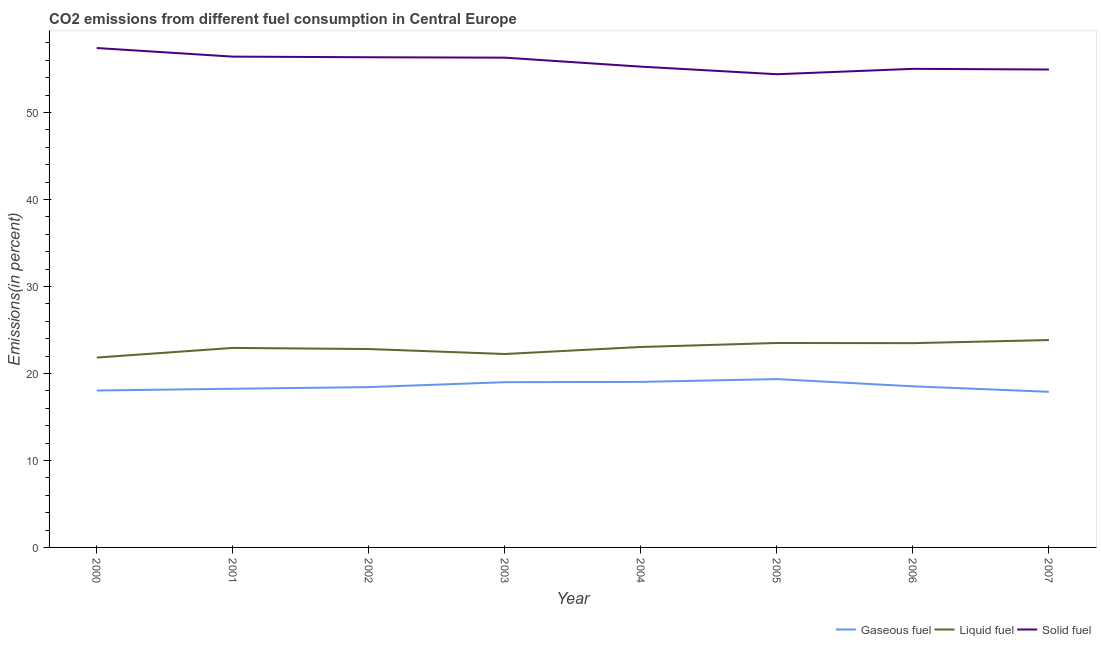Is the number of lines equal to the number of legend labels?
Your answer should be compact. Yes. What is the percentage of gaseous fuel emission in 2001?
Your answer should be very brief. 18.24. Across all years, what is the maximum percentage of liquid fuel emission?
Provide a short and direct response. 23.84. Across all years, what is the minimum percentage of gaseous fuel emission?
Your answer should be compact. 17.89. In which year was the percentage of solid fuel emission maximum?
Your response must be concise. 2000. In which year was the percentage of gaseous fuel emission minimum?
Your response must be concise. 2007. What is the total percentage of solid fuel emission in the graph?
Your response must be concise. 446.14. What is the difference between the percentage of solid fuel emission in 2001 and that in 2005?
Your response must be concise. 2.02. What is the difference between the percentage of liquid fuel emission in 2007 and the percentage of gaseous fuel emission in 2004?
Offer a very short reply. 4.81. What is the average percentage of liquid fuel emission per year?
Your answer should be very brief. 22.96. In the year 2002, what is the difference between the percentage of liquid fuel emission and percentage of gaseous fuel emission?
Give a very brief answer. 4.38. In how many years, is the percentage of gaseous fuel emission greater than 4 %?
Offer a terse response. 8. What is the ratio of the percentage of gaseous fuel emission in 2004 to that in 2007?
Offer a very short reply. 1.06. Is the percentage of solid fuel emission in 2001 less than that in 2004?
Provide a short and direct response. No. What is the difference between the highest and the second highest percentage of liquid fuel emission?
Ensure brevity in your answer.  0.34. What is the difference between the highest and the lowest percentage of gaseous fuel emission?
Ensure brevity in your answer.  1.46. Is the sum of the percentage of liquid fuel emission in 2006 and 2007 greater than the maximum percentage of gaseous fuel emission across all years?
Your response must be concise. Yes. Is it the case that in every year, the sum of the percentage of gaseous fuel emission and percentage of liquid fuel emission is greater than the percentage of solid fuel emission?
Your answer should be very brief. No. Does the percentage of gaseous fuel emission monotonically increase over the years?
Provide a succinct answer. No. Is the percentage of gaseous fuel emission strictly less than the percentage of liquid fuel emission over the years?
Keep it short and to the point. Yes. How many lines are there?
Provide a short and direct response. 3. How many years are there in the graph?
Make the answer very short. 8. Are the values on the major ticks of Y-axis written in scientific E-notation?
Provide a short and direct response. No. Does the graph contain grids?
Offer a terse response. No. What is the title of the graph?
Your answer should be compact. CO2 emissions from different fuel consumption in Central Europe. What is the label or title of the X-axis?
Your answer should be compact. Year. What is the label or title of the Y-axis?
Offer a terse response. Emissions(in percent). What is the Emissions(in percent) of Gaseous fuel in 2000?
Offer a terse response. 18.04. What is the Emissions(in percent) in Liquid fuel in 2000?
Make the answer very short. 21.83. What is the Emissions(in percent) in Solid fuel in 2000?
Offer a terse response. 57.42. What is the Emissions(in percent) in Gaseous fuel in 2001?
Provide a short and direct response. 18.24. What is the Emissions(in percent) in Liquid fuel in 2001?
Give a very brief answer. 22.94. What is the Emissions(in percent) in Solid fuel in 2001?
Your response must be concise. 56.43. What is the Emissions(in percent) in Gaseous fuel in 2002?
Offer a very short reply. 18.43. What is the Emissions(in percent) in Liquid fuel in 2002?
Make the answer very short. 22.81. What is the Emissions(in percent) of Solid fuel in 2002?
Your answer should be very brief. 56.35. What is the Emissions(in percent) of Gaseous fuel in 2003?
Make the answer very short. 19. What is the Emissions(in percent) in Liquid fuel in 2003?
Offer a terse response. 22.24. What is the Emissions(in percent) in Solid fuel in 2003?
Make the answer very short. 56.31. What is the Emissions(in percent) in Gaseous fuel in 2004?
Offer a very short reply. 19.03. What is the Emissions(in percent) in Liquid fuel in 2004?
Offer a terse response. 23.04. What is the Emissions(in percent) of Solid fuel in 2004?
Your answer should be very brief. 55.27. What is the Emissions(in percent) of Gaseous fuel in 2005?
Offer a terse response. 19.35. What is the Emissions(in percent) of Liquid fuel in 2005?
Provide a short and direct response. 23.5. What is the Emissions(in percent) in Solid fuel in 2005?
Provide a short and direct response. 54.4. What is the Emissions(in percent) of Gaseous fuel in 2006?
Keep it short and to the point. 18.52. What is the Emissions(in percent) in Liquid fuel in 2006?
Your answer should be very brief. 23.48. What is the Emissions(in percent) in Solid fuel in 2006?
Make the answer very short. 55.02. What is the Emissions(in percent) in Gaseous fuel in 2007?
Offer a terse response. 17.89. What is the Emissions(in percent) of Liquid fuel in 2007?
Provide a short and direct response. 23.84. What is the Emissions(in percent) of Solid fuel in 2007?
Ensure brevity in your answer.  54.94. Across all years, what is the maximum Emissions(in percent) in Gaseous fuel?
Keep it short and to the point. 19.35. Across all years, what is the maximum Emissions(in percent) in Liquid fuel?
Offer a terse response. 23.84. Across all years, what is the maximum Emissions(in percent) of Solid fuel?
Make the answer very short. 57.42. Across all years, what is the minimum Emissions(in percent) of Gaseous fuel?
Offer a very short reply. 17.89. Across all years, what is the minimum Emissions(in percent) of Liquid fuel?
Your answer should be very brief. 21.83. Across all years, what is the minimum Emissions(in percent) of Solid fuel?
Your answer should be compact. 54.4. What is the total Emissions(in percent) in Gaseous fuel in the graph?
Give a very brief answer. 148.51. What is the total Emissions(in percent) in Liquid fuel in the graph?
Provide a short and direct response. 183.69. What is the total Emissions(in percent) of Solid fuel in the graph?
Offer a terse response. 446.14. What is the difference between the Emissions(in percent) of Gaseous fuel in 2000 and that in 2001?
Your answer should be very brief. -0.2. What is the difference between the Emissions(in percent) in Liquid fuel in 2000 and that in 2001?
Offer a terse response. -1.11. What is the difference between the Emissions(in percent) in Gaseous fuel in 2000 and that in 2002?
Provide a short and direct response. -0.39. What is the difference between the Emissions(in percent) of Liquid fuel in 2000 and that in 2002?
Keep it short and to the point. -0.98. What is the difference between the Emissions(in percent) of Solid fuel in 2000 and that in 2002?
Offer a terse response. 1.06. What is the difference between the Emissions(in percent) in Gaseous fuel in 2000 and that in 2003?
Make the answer very short. -0.96. What is the difference between the Emissions(in percent) in Liquid fuel in 2000 and that in 2003?
Give a very brief answer. -0.41. What is the difference between the Emissions(in percent) of Solid fuel in 2000 and that in 2003?
Your answer should be compact. 1.11. What is the difference between the Emissions(in percent) in Gaseous fuel in 2000 and that in 2004?
Your answer should be very brief. -0.99. What is the difference between the Emissions(in percent) in Liquid fuel in 2000 and that in 2004?
Provide a short and direct response. -1.21. What is the difference between the Emissions(in percent) of Solid fuel in 2000 and that in 2004?
Your answer should be compact. 2.14. What is the difference between the Emissions(in percent) of Gaseous fuel in 2000 and that in 2005?
Your response must be concise. -1.31. What is the difference between the Emissions(in percent) of Liquid fuel in 2000 and that in 2005?
Keep it short and to the point. -1.67. What is the difference between the Emissions(in percent) of Solid fuel in 2000 and that in 2005?
Your answer should be very brief. 3.01. What is the difference between the Emissions(in percent) in Gaseous fuel in 2000 and that in 2006?
Offer a very short reply. -0.48. What is the difference between the Emissions(in percent) in Liquid fuel in 2000 and that in 2006?
Keep it short and to the point. -1.65. What is the difference between the Emissions(in percent) in Solid fuel in 2000 and that in 2006?
Give a very brief answer. 2.39. What is the difference between the Emissions(in percent) of Gaseous fuel in 2000 and that in 2007?
Offer a very short reply. 0.15. What is the difference between the Emissions(in percent) of Liquid fuel in 2000 and that in 2007?
Offer a terse response. -2.01. What is the difference between the Emissions(in percent) of Solid fuel in 2000 and that in 2007?
Your answer should be very brief. 2.47. What is the difference between the Emissions(in percent) of Gaseous fuel in 2001 and that in 2002?
Offer a terse response. -0.19. What is the difference between the Emissions(in percent) in Liquid fuel in 2001 and that in 2002?
Offer a terse response. 0.13. What is the difference between the Emissions(in percent) in Solid fuel in 2001 and that in 2002?
Keep it short and to the point. 0.07. What is the difference between the Emissions(in percent) in Gaseous fuel in 2001 and that in 2003?
Offer a terse response. -0.76. What is the difference between the Emissions(in percent) in Liquid fuel in 2001 and that in 2003?
Provide a short and direct response. 0.7. What is the difference between the Emissions(in percent) in Solid fuel in 2001 and that in 2003?
Give a very brief answer. 0.12. What is the difference between the Emissions(in percent) of Gaseous fuel in 2001 and that in 2004?
Keep it short and to the point. -0.79. What is the difference between the Emissions(in percent) of Liquid fuel in 2001 and that in 2004?
Provide a succinct answer. -0.11. What is the difference between the Emissions(in percent) in Solid fuel in 2001 and that in 2004?
Give a very brief answer. 1.15. What is the difference between the Emissions(in percent) in Gaseous fuel in 2001 and that in 2005?
Your response must be concise. -1.11. What is the difference between the Emissions(in percent) of Liquid fuel in 2001 and that in 2005?
Make the answer very short. -0.57. What is the difference between the Emissions(in percent) of Solid fuel in 2001 and that in 2005?
Give a very brief answer. 2.02. What is the difference between the Emissions(in percent) in Gaseous fuel in 2001 and that in 2006?
Your response must be concise. -0.28. What is the difference between the Emissions(in percent) of Liquid fuel in 2001 and that in 2006?
Your answer should be compact. -0.55. What is the difference between the Emissions(in percent) of Solid fuel in 2001 and that in 2006?
Ensure brevity in your answer.  1.4. What is the difference between the Emissions(in percent) of Gaseous fuel in 2001 and that in 2007?
Make the answer very short. 0.35. What is the difference between the Emissions(in percent) in Liquid fuel in 2001 and that in 2007?
Your answer should be compact. -0.91. What is the difference between the Emissions(in percent) of Solid fuel in 2001 and that in 2007?
Provide a short and direct response. 1.48. What is the difference between the Emissions(in percent) in Gaseous fuel in 2002 and that in 2003?
Your answer should be very brief. -0.57. What is the difference between the Emissions(in percent) in Liquid fuel in 2002 and that in 2003?
Your answer should be compact. 0.57. What is the difference between the Emissions(in percent) in Solid fuel in 2002 and that in 2003?
Your answer should be very brief. 0.05. What is the difference between the Emissions(in percent) of Gaseous fuel in 2002 and that in 2004?
Give a very brief answer. -0.6. What is the difference between the Emissions(in percent) in Liquid fuel in 2002 and that in 2004?
Your answer should be very brief. -0.24. What is the difference between the Emissions(in percent) in Solid fuel in 2002 and that in 2004?
Your response must be concise. 1.08. What is the difference between the Emissions(in percent) of Gaseous fuel in 2002 and that in 2005?
Your response must be concise. -0.92. What is the difference between the Emissions(in percent) of Liquid fuel in 2002 and that in 2005?
Your answer should be compact. -0.7. What is the difference between the Emissions(in percent) of Solid fuel in 2002 and that in 2005?
Your answer should be compact. 1.95. What is the difference between the Emissions(in percent) of Gaseous fuel in 2002 and that in 2006?
Ensure brevity in your answer.  -0.09. What is the difference between the Emissions(in percent) in Liquid fuel in 2002 and that in 2006?
Offer a terse response. -0.68. What is the difference between the Emissions(in percent) in Solid fuel in 2002 and that in 2006?
Keep it short and to the point. 1.33. What is the difference between the Emissions(in percent) of Gaseous fuel in 2002 and that in 2007?
Offer a terse response. 0.54. What is the difference between the Emissions(in percent) in Liquid fuel in 2002 and that in 2007?
Keep it short and to the point. -1.03. What is the difference between the Emissions(in percent) of Solid fuel in 2002 and that in 2007?
Your answer should be very brief. 1.41. What is the difference between the Emissions(in percent) of Gaseous fuel in 2003 and that in 2004?
Ensure brevity in your answer.  -0.03. What is the difference between the Emissions(in percent) of Liquid fuel in 2003 and that in 2004?
Provide a succinct answer. -0.81. What is the difference between the Emissions(in percent) in Solid fuel in 2003 and that in 2004?
Offer a terse response. 1.03. What is the difference between the Emissions(in percent) of Gaseous fuel in 2003 and that in 2005?
Offer a very short reply. -0.36. What is the difference between the Emissions(in percent) of Liquid fuel in 2003 and that in 2005?
Your answer should be compact. -1.27. What is the difference between the Emissions(in percent) of Solid fuel in 2003 and that in 2005?
Make the answer very short. 1.91. What is the difference between the Emissions(in percent) of Gaseous fuel in 2003 and that in 2006?
Give a very brief answer. 0.47. What is the difference between the Emissions(in percent) in Liquid fuel in 2003 and that in 2006?
Your answer should be compact. -1.25. What is the difference between the Emissions(in percent) in Solid fuel in 2003 and that in 2006?
Your answer should be compact. 1.29. What is the difference between the Emissions(in percent) in Gaseous fuel in 2003 and that in 2007?
Give a very brief answer. 1.11. What is the difference between the Emissions(in percent) in Liquid fuel in 2003 and that in 2007?
Provide a short and direct response. -1.6. What is the difference between the Emissions(in percent) of Solid fuel in 2003 and that in 2007?
Make the answer very short. 1.36. What is the difference between the Emissions(in percent) of Gaseous fuel in 2004 and that in 2005?
Give a very brief answer. -0.32. What is the difference between the Emissions(in percent) in Liquid fuel in 2004 and that in 2005?
Offer a terse response. -0.46. What is the difference between the Emissions(in percent) in Solid fuel in 2004 and that in 2005?
Your response must be concise. 0.87. What is the difference between the Emissions(in percent) in Gaseous fuel in 2004 and that in 2006?
Ensure brevity in your answer.  0.51. What is the difference between the Emissions(in percent) in Liquid fuel in 2004 and that in 2006?
Provide a succinct answer. -0.44. What is the difference between the Emissions(in percent) of Solid fuel in 2004 and that in 2006?
Provide a short and direct response. 0.25. What is the difference between the Emissions(in percent) of Gaseous fuel in 2004 and that in 2007?
Offer a terse response. 1.14. What is the difference between the Emissions(in percent) in Liquid fuel in 2004 and that in 2007?
Ensure brevity in your answer.  -0.8. What is the difference between the Emissions(in percent) of Solid fuel in 2004 and that in 2007?
Provide a short and direct response. 0.33. What is the difference between the Emissions(in percent) in Gaseous fuel in 2005 and that in 2006?
Ensure brevity in your answer.  0.83. What is the difference between the Emissions(in percent) in Liquid fuel in 2005 and that in 2006?
Provide a succinct answer. 0.02. What is the difference between the Emissions(in percent) in Solid fuel in 2005 and that in 2006?
Offer a very short reply. -0.62. What is the difference between the Emissions(in percent) in Gaseous fuel in 2005 and that in 2007?
Offer a very short reply. 1.46. What is the difference between the Emissions(in percent) of Liquid fuel in 2005 and that in 2007?
Ensure brevity in your answer.  -0.34. What is the difference between the Emissions(in percent) of Solid fuel in 2005 and that in 2007?
Make the answer very short. -0.54. What is the difference between the Emissions(in percent) of Gaseous fuel in 2006 and that in 2007?
Your answer should be very brief. 0.63. What is the difference between the Emissions(in percent) in Liquid fuel in 2006 and that in 2007?
Your answer should be compact. -0.36. What is the difference between the Emissions(in percent) of Solid fuel in 2006 and that in 2007?
Keep it short and to the point. 0.08. What is the difference between the Emissions(in percent) of Gaseous fuel in 2000 and the Emissions(in percent) of Liquid fuel in 2001?
Offer a terse response. -4.9. What is the difference between the Emissions(in percent) in Gaseous fuel in 2000 and the Emissions(in percent) in Solid fuel in 2001?
Provide a succinct answer. -38.39. What is the difference between the Emissions(in percent) in Liquid fuel in 2000 and the Emissions(in percent) in Solid fuel in 2001?
Your answer should be very brief. -34.6. What is the difference between the Emissions(in percent) in Gaseous fuel in 2000 and the Emissions(in percent) in Liquid fuel in 2002?
Ensure brevity in your answer.  -4.77. What is the difference between the Emissions(in percent) of Gaseous fuel in 2000 and the Emissions(in percent) of Solid fuel in 2002?
Offer a very short reply. -38.31. What is the difference between the Emissions(in percent) in Liquid fuel in 2000 and the Emissions(in percent) in Solid fuel in 2002?
Your answer should be very brief. -34.52. What is the difference between the Emissions(in percent) of Gaseous fuel in 2000 and the Emissions(in percent) of Liquid fuel in 2003?
Your response must be concise. -4.2. What is the difference between the Emissions(in percent) of Gaseous fuel in 2000 and the Emissions(in percent) of Solid fuel in 2003?
Provide a short and direct response. -38.27. What is the difference between the Emissions(in percent) of Liquid fuel in 2000 and the Emissions(in percent) of Solid fuel in 2003?
Your answer should be compact. -34.48. What is the difference between the Emissions(in percent) of Gaseous fuel in 2000 and the Emissions(in percent) of Liquid fuel in 2004?
Your response must be concise. -5. What is the difference between the Emissions(in percent) in Gaseous fuel in 2000 and the Emissions(in percent) in Solid fuel in 2004?
Offer a very short reply. -37.23. What is the difference between the Emissions(in percent) of Liquid fuel in 2000 and the Emissions(in percent) of Solid fuel in 2004?
Your answer should be very brief. -33.44. What is the difference between the Emissions(in percent) of Gaseous fuel in 2000 and the Emissions(in percent) of Liquid fuel in 2005?
Offer a very short reply. -5.46. What is the difference between the Emissions(in percent) in Gaseous fuel in 2000 and the Emissions(in percent) in Solid fuel in 2005?
Offer a very short reply. -36.36. What is the difference between the Emissions(in percent) of Liquid fuel in 2000 and the Emissions(in percent) of Solid fuel in 2005?
Your response must be concise. -32.57. What is the difference between the Emissions(in percent) in Gaseous fuel in 2000 and the Emissions(in percent) in Liquid fuel in 2006?
Your answer should be very brief. -5.44. What is the difference between the Emissions(in percent) in Gaseous fuel in 2000 and the Emissions(in percent) in Solid fuel in 2006?
Your answer should be compact. -36.98. What is the difference between the Emissions(in percent) of Liquid fuel in 2000 and the Emissions(in percent) of Solid fuel in 2006?
Keep it short and to the point. -33.19. What is the difference between the Emissions(in percent) in Gaseous fuel in 2000 and the Emissions(in percent) in Liquid fuel in 2007?
Offer a terse response. -5.8. What is the difference between the Emissions(in percent) in Gaseous fuel in 2000 and the Emissions(in percent) in Solid fuel in 2007?
Ensure brevity in your answer.  -36.9. What is the difference between the Emissions(in percent) in Liquid fuel in 2000 and the Emissions(in percent) in Solid fuel in 2007?
Your response must be concise. -33.11. What is the difference between the Emissions(in percent) of Gaseous fuel in 2001 and the Emissions(in percent) of Liquid fuel in 2002?
Make the answer very short. -4.57. What is the difference between the Emissions(in percent) of Gaseous fuel in 2001 and the Emissions(in percent) of Solid fuel in 2002?
Offer a very short reply. -38.11. What is the difference between the Emissions(in percent) in Liquid fuel in 2001 and the Emissions(in percent) in Solid fuel in 2002?
Your response must be concise. -33.42. What is the difference between the Emissions(in percent) of Gaseous fuel in 2001 and the Emissions(in percent) of Liquid fuel in 2003?
Provide a short and direct response. -4. What is the difference between the Emissions(in percent) of Gaseous fuel in 2001 and the Emissions(in percent) of Solid fuel in 2003?
Your answer should be compact. -38.07. What is the difference between the Emissions(in percent) of Liquid fuel in 2001 and the Emissions(in percent) of Solid fuel in 2003?
Your response must be concise. -33.37. What is the difference between the Emissions(in percent) of Gaseous fuel in 2001 and the Emissions(in percent) of Liquid fuel in 2004?
Your answer should be compact. -4.8. What is the difference between the Emissions(in percent) in Gaseous fuel in 2001 and the Emissions(in percent) in Solid fuel in 2004?
Your answer should be compact. -37.03. What is the difference between the Emissions(in percent) of Liquid fuel in 2001 and the Emissions(in percent) of Solid fuel in 2004?
Provide a short and direct response. -32.34. What is the difference between the Emissions(in percent) in Gaseous fuel in 2001 and the Emissions(in percent) in Liquid fuel in 2005?
Provide a short and direct response. -5.26. What is the difference between the Emissions(in percent) in Gaseous fuel in 2001 and the Emissions(in percent) in Solid fuel in 2005?
Your answer should be compact. -36.16. What is the difference between the Emissions(in percent) of Liquid fuel in 2001 and the Emissions(in percent) of Solid fuel in 2005?
Give a very brief answer. -31.46. What is the difference between the Emissions(in percent) of Gaseous fuel in 2001 and the Emissions(in percent) of Liquid fuel in 2006?
Ensure brevity in your answer.  -5.24. What is the difference between the Emissions(in percent) of Gaseous fuel in 2001 and the Emissions(in percent) of Solid fuel in 2006?
Offer a terse response. -36.78. What is the difference between the Emissions(in percent) of Liquid fuel in 2001 and the Emissions(in percent) of Solid fuel in 2006?
Keep it short and to the point. -32.08. What is the difference between the Emissions(in percent) of Gaseous fuel in 2001 and the Emissions(in percent) of Liquid fuel in 2007?
Your answer should be compact. -5.6. What is the difference between the Emissions(in percent) in Gaseous fuel in 2001 and the Emissions(in percent) in Solid fuel in 2007?
Your answer should be compact. -36.7. What is the difference between the Emissions(in percent) of Liquid fuel in 2001 and the Emissions(in percent) of Solid fuel in 2007?
Make the answer very short. -32.01. What is the difference between the Emissions(in percent) of Gaseous fuel in 2002 and the Emissions(in percent) of Liquid fuel in 2003?
Ensure brevity in your answer.  -3.81. What is the difference between the Emissions(in percent) of Gaseous fuel in 2002 and the Emissions(in percent) of Solid fuel in 2003?
Your answer should be compact. -37.88. What is the difference between the Emissions(in percent) in Liquid fuel in 2002 and the Emissions(in percent) in Solid fuel in 2003?
Provide a succinct answer. -33.5. What is the difference between the Emissions(in percent) in Gaseous fuel in 2002 and the Emissions(in percent) in Liquid fuel in 2004?
Provide a short and direct response. -4.61. What is the difference between the Emissions(in percent) in Gaseous fuel in 2002 and the Emissions(in percent) in Solid fuel in 2004?
Offer a very short reply. -36.84. What is the difference between the Emissions(in percent) in Liquid fuel in 2002 and the Emissions(in percent) in Solid fuel in 2004?
Ensure brevity in your answer.  -32.47. What is the difference between the Emissions(in percent) of Gaseous fuel in 2002 and the Emissions(in percent) of Liquid fuel in 2005?
Make the answer very short. -5.07. What is the difference between the Emissions(in percent) of Gaseous fuel in 2002 and the Emissions(in percent) of Solid fuel in 2005?
Offer a very short reply. -35.97. What is the difference between the Emissions(in percent) in Liquid fuel in 2002 and the Emissions(in percent) in Solid fuel in 2005?
Your answer should be very brief. -31.59. What is the difference between the Emissions(in percent) of Gaseous fuel in 2002 and the Emissions(in percent) of Liquid fuel in 2006?
Keep it short and to the point. -5.05. What is the difference between the Emissions(in percent) in Gaseous fuel in 2002 and the Emissions(in percent) in Solid fuel in 2006?
Keep it short and to the point. -36.59. What is the difference between the Emissions(in percent) of Liquid fuel in 2002 and the Emissions(in percent) of Solid fuel in 2006?
Offer a terse response. -32.21. What is the difference between the Emissions(in percent) in Gaseous fuel in 2002 and the Emissions(in percent) in Liquid fuel in 2007?
Keep it short and to the point. -5.41. What is the difference between the Emissions(in percent) in Gaseous fuel in 2002 and the Emissions(in percent) in Solid fuel in 2007?
Your answer should be very brief. -36.51. What is the difference between the Emissions(in percent) in Liquid fuel in 2002 and the Emissions(in percent) in Solid fuel in 2007?
Your answer should be very brief. -32.13. What is the difference between the Emissions(in percent) in Gaseous fuel in 2003 and the Emissions(in percent) in Liquid fuel in 2004?
Provide a short and direct response. -4.05. What is the difference between the Emissions(in percent) of Gaseous fuel in 2003 and the Emissions(in percent) of Solid fuel in 2004?
Give a very brief answer. -36.28. What is the difference between the Emissions(in percent) in Liquid fuel in 2003 and the Emissions(in percent) in Solid fuel in 2004?
Offer a terse response. -33.04. What is the difference between the Emissions(in percent) in Gaseous fuel in 2003 and the Emissions(in percent) in Liquid fuel in 2005?
Keep it short and to the point. -4.51. What is the difference between the Emissions(in percent) of Gaseous fuel in 2003 and the Emissions(in percent) of Solid fuel in 2005?
Give a very brief answer. -35.4. What is the difference between the Emissions(in percent) of Liquid fuel in 2003 and the Emissions(in percent) of Solid fuel in 2005?
Keep it short and to the point. -32.16. What is the difference between the Emissions(in percent) of Gaseous fuel in 2003 and the Emissions(in percent) of Liquid fuel in 2006?
Give a very brief answer. -4.49. What is the difference between the Emissions(in percent) of Gaseous fuel in 2003 and the Emissions(in percent) of Solid fuel in 2006?
Offer a very short reply. -36.02. What is the difference between the Emissions(in percent) of Liquid fuel in 2003 and the Emissions(in percent) of Solid fuel in 2006?
Your answer should be compact. -32.78. What is the difference between the Emissions(in percent) of Gaseous fuel in 2003 and the Emissions(in percent) of Liquid fuel in 2007?
Provide a succinct answer. -4.85. What is the difference between the Emissions(in percent) in Gaseous fuel in 2003 and the Emissions(in percent) in Solid fuel in 2007?
Provide a short and direct response. -35.95. What is the difference between the Emissions(in percent) of Liquid fuel in 2003 and the Emissions(in percent) of Solid fuel in 2007?
Your response must be concise. -32.7. What is the difference between the Emissions(in percent) of Gaseous fuel in 2004 and the Emissions(in percent) of Liquid fuel in 2005?
Make the answer very short. -4.48. What is the difference between the Emissions(in percent) of Gaseous fuel in 2004 and the Emissions(in percent) of Solid fuel in 2005?
Give a very brief answer. -35.37. What is the difference between the Emissions(in percent) in Liquid fuel in 2004 and the Emissions(in percent) in Solid fuel in 2005?
Your response must be concise. -31.36. What is the difference between the Emissions(in percent) of Gaseous fuel in 2004 and the Emissions(in percent) of Liquid fuel in 2006?
Ensure brevity in your answer.  -4.46. What is the difference between the Emissions(in percent) of Gaseous fuel in 2004 and the Emissions(in percent) of Solid fuel in 2006?
Provide a succinct answer. -35.99. What is the difference between the Emissions(in percent) of Liquid fuel in 2004 and the Emissions(in percent) of Solid fuel in 2006?
Ensure brevity in your answer.  -31.98. What is the difference between the Emissions(in percent) in Gaseous fuel in 2004 and the Emissions(in percent) in Liquid fuel in 2007?
Keep it short and to the point. -4.81. What is the difference between the Emissions(in percent) in Gaseous fuel in 2004 and the Emissions(in percent) in Solid fuel in 2007?
Provide a succinct answer. -35.91. What is the difference between the Emissions(in percent) in Liquid fuel in 2004 and the Emissions(in percent) in Solid fuel in 2007?
Give a very brief answer. -31.9. What is the difference between the Emissions(in percent) in Gaseous fuel in 2005 and the Emissions(in percent) in Liquid fuel in 2006?
Make the answer very short. -4.13. What is the difference between the Emissions(in percent) in Gaseous fuel in 2005 and the Emissions(in percent) in Solid fuel in 2006?
Offer a very short reply. -35.67. What is the difference between the Emissions(in percent) in Liquid fuel in 2005 and the Emissions(in percent) in Solid fuel in 2006?
Offer a terse response. -31.52. What is the difference between the Emissions(in percent) of Gaseous fuel in 2005 and the Emissions(in percent) of Liquid fuel in 2007?
Ensure brevity in your answer.  -4.49. What is the difference between the Emissions(in percent) in Gaseous fuel in 2005 and the Emissions(in percent) in Solid fuel in 2007?
Your answer should be very brief. -35.59. What is the difference between the Emissions(in percent) of Liquid fuel in 2005 and the Emissions(in percent) of Solid fuel in 2007?
Give a very brief answer. -31.44. What is the difference between the Emissions(in percent) of Gaseous fuel in 2006 and the Emissions(in percent) of Liquid fuel in 2007?
Offer a terse response. -5.32. What is the difference between the Emissions(in percent) in Gaseous fuel in 2006 and the Emissions(in percent) in Solid fuel in 2007?
Ensure brevity in your answer.  -36.42. What is the difference between the Emissions(in percent) of Liquid fuel in 2006 and the Emissions(in percent) of Solid fuel in 2007?
Your answer should be compact. -31.46. What is the average Emissions(in percent) in Gaseous fuel per year?
Give a very brief answer. 18.56. What is the average Emissions(in percent) in Liquid fuel per year?
Your response must be concise. 22.96. What is the average Emissions(in percent) of Solid fuel per year?
Your answer should be very brief. 55.77. In the year 2000, what is the difference between the Emissions(in percent) of Gaseous fuel and Emissions(in percent) of Liquid fuel?
Provide a succinct answer. -3.79. In the year 2000, what is the difference between the Emissions(in percent) in Gaseous fuel and Emissions(in percent) in Solid fuel?
Your answer should be very brief. -39.38. In the year 2000, what is the difference between the Emissions(in percent) in Liquid fuel and Emissions(in percent) in Solid fuel?
Your response must be concise. -35.59. In the year 2001, what is the difference between the Emissions(in percent) of Gaseous fuel and Emissions(in percent) of Liquid fuel?
Offer a very short reply. -4.69. In the year 2001, what is the difference between the Emissions(in percent) of Gaseous fuel and Emissions(in percent) of Solid fuel?
Keep it short and to the point. -38.18. In the year 2001, what is the difference between the Emissions(in percent) of Liquid fuel and Emissions(in percent) of Solid fuel?
Offer a very short reply. -33.49. In the year 2002, what is the difference between the Emissions(in percent) of Gaseous fuel and Emissions(in percent) of Liquid fuel?
Your answer should be very brief. -4.38. In the year 2002, what is the difference between the Emissions(in percent) of Gaseous fuel and Emissions(in percent) of Solid fuel?
Offer a very short reply. -37.92. In the year 2002, what is the difference between the Emissions(in percent) in Liquid fuel and Emissions(in percent) in Solid fuel?
Keep it short and to the point. -33.55. In the year 2003, what is the difference between the Emissions(in percent) of Gaseous fuel and Emissions(in percent) of Liquid fuel?
Provide a short and direct response. -3.24. In the year 2003, what is the difference between the Emissions(in percent) in Gaseous fuel and Emissions(in percent) in Solid fuel?
Your answer should be very brief. -37.31. In the year 2003, what is the difference between the Emissions(in percent) of Liquid fuel and Emissions(in percent) of Solid fuel?
Provide a short and direct response. -34.07. In the year 2004, what is the difference between the Emissions(in percent) in Gaseous fuel and Emissions(in percent) in Liquid fuel?
Offer a terse response. -4.02. In the year 2004, what is the difference between the Emissions(in percent) in Gaseous fuel and Emissions(in percent) in Solid fuel?
Provide a short and direct response. -36.24. In the year 2004, what is the difference between the Emissions(in percent) in Liquid fuel and Emissions(in percent) in Solid fuel?
Make the answer very short. -32.23. In the year 2005, what is the difference between the Emissions(in percent) in Gaseous fuel and Emissions(in percent) in Liquid fuel?
Your answer should be very brief. -4.15. In the year 2005, what is the difference between the Emissions(in percent) of Gaseous fuel and Emissions(in percent) of Solid fuel?
Ensure brevity in your answer.  -35.05. In the year 2005, what is the difference between the Emissions(in percent) of Liquid fuel and Emissions(in percent) of Solid fuel?
Make the answer very short. -30.9. In the year 2006, what is the difference between the Emissions(in percent) of Gaseous fuel and Emissions(in percent) of Liquid fuel?
Make the answer very short. -4.96. In the year 2006, what is the difference between the Emissions(in percent) of Gaseous fuel and Emissions(in percent) of Solid fuel?
Ensure brevity in your answer.  -36.5. In the year 2006, what is the difference between the Emissions(in percent) of Liquid fuel and Emissions(in percent) of Solid fuel?
Make the answer very short. -31.54. In the year 2007, what is the difference between the Emissions(in percent) in Gaseous fuel and Emissions(in percent) in Liquid fuel?
Offer a terse response. -5.95. In the year 2007, what is the difference between the Emissions(in percent) of Gaseous fuel and Emissions(in percent) of Solid fuel?
Keep it short and to the point. -37.05. In the year 2007, what is the difference between the Emissions(in percent) in Liquid fuel and Emissions(in percent) in Solid fuel?
Provide a short and direct response. -31.1. What is the ratio of the Emissions(in percent) in Gaseous fuel in 2000 to that in 2001?
Offer a very short reply. 0.99. What is the ratio of the Emissions(in percent) of Liquid fuel in 2000 to that in 2001?
Provide a short and direct response. 0.95. What is the ratio of the Emissions(in percent) in Solid fuel in 2000 to that in 2001?
Keep it short and to the point. 1.02. What is the ratio of the Emissions(in percent) in Gaseous fuel in 2000 to that in 2002?
Ensure brevity in your answer.  0.98. What is the ratio of the Emissions(in percent) of Liquid fuel in 2000 to that in 2002?
Provide a succinct answer. 0.96. What is the ratio of the Emissions(in percent) in Solid fuel in 2000 to that in 2002?
Ensure brevity in your answer.  1.02. What is the ratio of the Emissions(in percent) of Gaseous fuel in 2000 to that in 2003?
Your answer should be compact. 0.95. What is the ratio of the Emissions(in percent) in Liquid fuel in 2000 to that in 2003?
Keep it short and to the point. 0.98. What is the ratio of the Emissions(in percent) of Solid fuel in 2000 to that in 2003?
Keep it short and to the point. 1.02. What is the ratio of the Emissions(in percent) in Gaseous fuel in 2000 to that in 2004?
Your answer should be very brief. 0.95. What is the ratio of the Emissions(in percent) of Liquid fuel in 2000 to that in 2004?
Make the answer very short. 0.95. What is the ratio of the Emissions(in percent) in Solid fuel in 2000 to that in 2004?
Keep it short and to the point. 1.04. What is the ratio of the Emissions(in percent) in Gaseous fuel in 2000 to that in 2005?
Your answer should be very brief. 0.93. What is the ratio of the Emissions(in percent) in Liquid fuel in 2000 to that in 2005?
Provide a succinct answer. 0.93. What is the ratio of the Emissions(in percent) in Solid fuel in 2000 to that in 2005?
Provide a succinct answer. 1.06. What is the ratio of the Emissions(in percent) in Gaseous fuel in 2000 to that in 2006?
Your answer should be very brief. 0.97. What is the ratio of the Emissions(in percent) in Liquid fuel in 2000 to that in 2006?
Offer a very short reply. 0.93. What is the ratio of the Emissions(in percent) of Solid fuel in 2000 to that in 2006?
Provide a succinct answer. 1.04. What is the ratio of the Emissions(in percent) in Gaseous fuel in 2000 to that in 2007?
Provide a short and direct response. 1.01. What is the ratio of the Emissions(in percent) in Liquid fuel in 2000 to that in 2007?
Ensure brevity in your answer.  0.92. What is the ratio of the Emissions(in percent) of Solid fuel in 2000 to that in 2007?
Your answer should be compact. 1.04. What is the ratio of the Emissions(in percent) of Liquid fuel in 2001 to that in 2002?
Give a very brief answer. 1.01. What is the ratio of the Emissions(in percent) in Solid fuel in 2001 to that in 2002?
Offer a very short reply. 1. What is the ratio of the Emissions(in percent) of Gaseous fuel in 2001 to that in 2003?
Provide a succinct answer. 0.96. What is the ratio of the Emissions(in percent) of Liquid fuel in 2001 to that in 2003?
Your answer should be compact. 1.03. What is the ratio of the Emissions(in percent) in Gaseous fuel in 2001 to that in 2004?
Give a very brief answer. 0.96. What is the ratio of the Emissions(in percent) of Liquid fuel in 2001 to that in 2004?
Offer a very short reply. 1. What is the ratio of the Emissions(in percent) of Solid fuel in 2001 to that in 2004?
Give a very brief answer. 1.02. What is the ratio of the Emissions(in percent) of Gaseous fuel in 2001 to that in 2005?
Your response must be concise. 0.94. What is the ratio of the Emissions(in percent) in Liquid fuel in 2001 to that in 2005?
Provide a short and direct response. 0.98. What is the ratio of the Emissions(in percent) of Solid fuel in 2001 to that in 2005?
Offer a very short reply. 1.04. What is the ratio of the Emissions(in percent) of Gaseous fuel in 2001 to that in 2006?
Your answer should be very brief. 0.98. What is the ratio of the Emissions(in percent) of Liquid fuel in 2001 to that in 2006?
Offer a terse response. 0.98. What is the ratio of the Emissions(in percent) in Solid fuel in 2001 to that in 2006?
Provide a succinct answer. 1.03. What is the ratio of the Emissions(in percent) in Gaseous fuel in 2001 to that in 2007?
Ensure brevity in your answer.  1.02. What is the ratio of the Emissions(in percent) in Liquid fuel in 2001 to that in 2007?
Give a very brief answer. 0.96. What is the ratio of the Emissions(in percent) of Solid fuel in 2001 to that in 2007?
Give a very brief answer. 1.03. What is the ratio of the Emissions(in percent) in Gaseous fuel in 2002 to that in 2003?
Keep it short and to the point. 0.97. What is the ratio of the Emissions(in percent) of Liquid fuel in 2002 to that in 2003?
Give a very brief answer. 1.03. What is the ratio of the Emissions(in percent) of Solid fuel in 2002 to that in 2003?
Keep it short and to the point. 1. What is the ratio of the Emissions(in percent) in Gaseous fuel in 2002 to that in 2004?
Provide a succinct answer. 0.97. What is the ratio of the Emissions(in percent) of Liquid fuel in 2002 to that in 2004?
Ensure brevity in your answer.  0.99. What is the ratio of the Emissions(in percent) in Solid fuel in 2002 to that in 2004?
Offer a very short reply. 1.02. What is the ratio of the Emissions(in percent) of Liquid fuel in 2002 to that in 2005?
Your answer should be very brief. 0.97. What is the ratio of the Emissions(in percent) in Solid fuel in 2002 to that in 2005?
Offer a terse response. 1.04. What is the ratio of the Emissions(in percent) in Gaseous fuel in 2002 to that in 2006?
Provide a short and direct response. 1. What is the ratio of the Emissions(in percent) of Liquid fuel in 2002 to that in 2006?
Offer a terse response. 0.97. What is the ratio of the Emissions(in percent) in Solid fuel in 2002 to that in 2006?
Offer a terse response. 1.02. What is the ratio of the Emissions(in percent) of Gaseous fuel in 2002 to that in 2007?
Provide a short and direct response. 1.03. What is the ratio of the Emissions(in percent) in Liquid fuel in 2002 to that in 2007?
Ensure brevity in your answer.  0.96. What is the ratio of the Emissions(in percent) in Solid fuel in 2002 to that in 2007?
Offer a terse response. 1.03. What is the ratio of the Emissions(in percent) of Liquid fuel in 2003 to that in 2004?
Make the answer very short. 0.96. What is the ratio of the Emissions(in percent) in Solid fuel in 2003 to that in 2004?
Make the answer very short. 1.02. What is the ratio of the Emissions(in percent) of Gaseous fuel in 2003 to that in 2005?
Your answer should be very brief. 0.98. What is the ratio of the Emissions(in percent) in Liquid fuel in 2003 to that in 2005?
Offer a very short reply. 0.95. What is the ratio of the Emissions(in percent) of Solid fuel in 2003 to that in 2005?
Keep it short and to the point. 1.03. What is the ratio of the Emissions(in percent) in Gaseous fuel in 2003 to that in 2006?
Ensure brevity in your answer.  1.03. What is the ratio of the Emissions(in percent) in Liquid fuel in 2003 to that in 2006?
Give a very brief answer. 0.95. What is the ratio of the Emissions(in percent) of Solid fuel in 2003 to that in 2006?
Provide a short and direct response. 1.02. What is the ratio of the Emissions(in percent) of Gaseous fuel in 2003 to that in 2007?
Your response must be concise. 1.06. What is the ratio of the Emissions(in percent) in Liquid fuel in 2003 to that in 2007?
Provide a short and direct response. 0.93. What is the ratio of the Emissions(in percent) of Solid fuel in 2003 to that in 2007?
Keep it short and to the point. 1.02. What is the ratio of the Emissions(in percent) in Gaseous fuel in 2004 to that in 2005?
Provide a short and direct response. 0.98. What is the ratio of the Emissions(in percent) of Liquid fuel in 2004 to that in 2005?
Offer a terse response. 0.98. What is the ratio of the Emissions(in percent) of Gaseous fuel in 2004 to that in 2006?
Provide a short and direct response. 1.03. What is the ratio of the Emissions(in percent) of Liquid fuel in 2004 to that in 2006?
Give a very brief answer. 0.98. What is the ratio of the Emissions(in percent) in Gaseous fuel in 2004 to that in 2007?
Offer a terse response. 1.06. What is the ratio of the Emissions(in percent) of Liquid fuel in 2004 to that in 2007?
Make the answer very short. 0.97. What is the ratio of the Emissions(in percent) of Gaseous fuel in 2005 to that in 2006?
Offer a very short reply. 1.04. What is the ratio of the Emissions(in percent) of Liquid fuel in 2005 to that in 2006?
Your answer should be compact. 1. What is the ratio of the Emissions(in percent) in Solid fuel in 2005 to that in 2006?
Offer a terse response. 0.99. What is the ratio of the Emissions(in percent) in Gaseous fuel in 2005 to that in 2007?
Make the answer very short. 1.08. What is the ratio of the Emissions(in percent) of Liquid fuel in 2005 to that in 2007?
Offer a terse response. 0.99. What is the ratio of the Emissions(in percent) of Solid fuel in 2005 to that in 2007?
Give a very brief answer. 0.99. What is the ratio of the Emissions(in percent) in Gaseous fuel in 2006 to that in 2007?
Your answer should be very brief. 1.04. What is the ratio of the Emissions(in percent) in Liquid fuel in 2006 to that in 2007?
Offer a very short reply. 0.98. What is the ratio of the Emissions(in percent) of Solid fuel in 2006 to that in 2007?
Give a very brief answer. 1. What is the difference between the highest and the second highest Emissions(in percent) in Gaseous fuel?
Keep it short and to the point. 0.32. What is the difference between the highest and the second highest Emissions(in percent) in Liquid fuel?
Offer a very short reply. 0.34. What is the difference between the highest and the second highest Emissions(in percent) in Solid fuel?
Your answer should be very brief. 0.99. What is the difference between the highest and the lowest Emissions(in percent) in Gaseous fuel?
Provide a succinct answer. 1.46. What is the difference between the highest and the lowest Emissions(in percent) of Liquid fuel?
Your answer should be very brief. 2.01. What is the difference between the highest and the lowest Emissions(in percent) of Solid fuel?
Your answer should be compact. 3.01. 